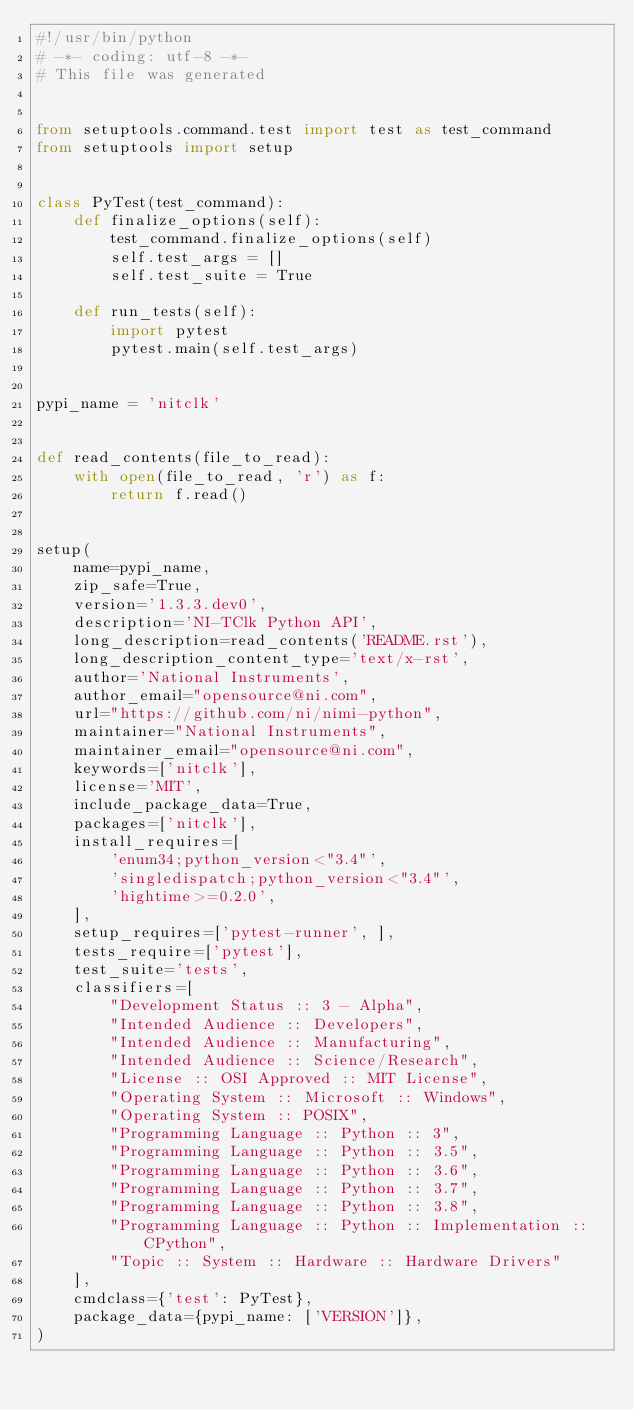Convert code to text. <code><loc_0><loc_0><loc_500><loc_500><_Python_>#!/usr/bin/python
# -*- coding: utf-8 -*-
# This file was generated


from setuptools.command.test import test as test_command
from setuptools import setup


class PyTest(test_command):
    def finalize_options(self):
        test_command.finalize_options(self)
        self.test_args = []
        self.test_suite = True

    def run_tests(self):
        import pytest
        pytest.main(self.test_args)


pypi_name = 'nitclk'


def read_contents(file_to_read):
    with open(file_to_read, 'r') as f:
        return f.read()


setup(
    name=pypi_name,
    zip_safe=True,
    version='1.3.3.dev0',
    description='NI-TClk Python API',
    long_description=read_contents('README.rst'),
    long_description_content_type='text/x-rst',
    author='National Instruments',
    author_email="opensource@ni.com",
    url="https://github.com/ni/nimi-python",
    maintainer="National Instruments",
    maintainer_email="opensource@ni.com",
    keywords=['nitclk'],
    license='MIT',
    include_package_data=True,
    packages=['nitclk'],
    install_requires=[
        'enum34;python_version<"3.4"',
        'singledispatch;python_version<"3.4"',
        'hightime>=0.2.0',
    ],
    setup_requires=['pytest-runner', ],
    tests_require=['pytest'],
    test_suite='tests',
    classifiers=[
        "Development Status :: 3 - Alpha",
        "Intended Audience :: Developers",
        "Intended Audience :: Manufacturing",
        "Intended Audience :: Science/Research",
        "License :: OSI Approved :: MIT License",
        "Operating System :: Microsoft :: Windows",
        "Operating System :: POSIX",
        "Programming Language :: Python :: 3",
        "Programming Language :: Python :: 3.5",
        "Programming Language :: Python :: 3.6",
        "Programming Language :: Python :: 3.7",
        "Programming Language :: Python :: 3.8",
        "Programming Language :: Python :: Implementation :: CPython",
        "Topic :: System :: Hardware :: Hardware Drivers"
    ],
    cmdclass={'test': PyTest},
    package_data={pypi_name: ['VERSION']},
)
</code> 